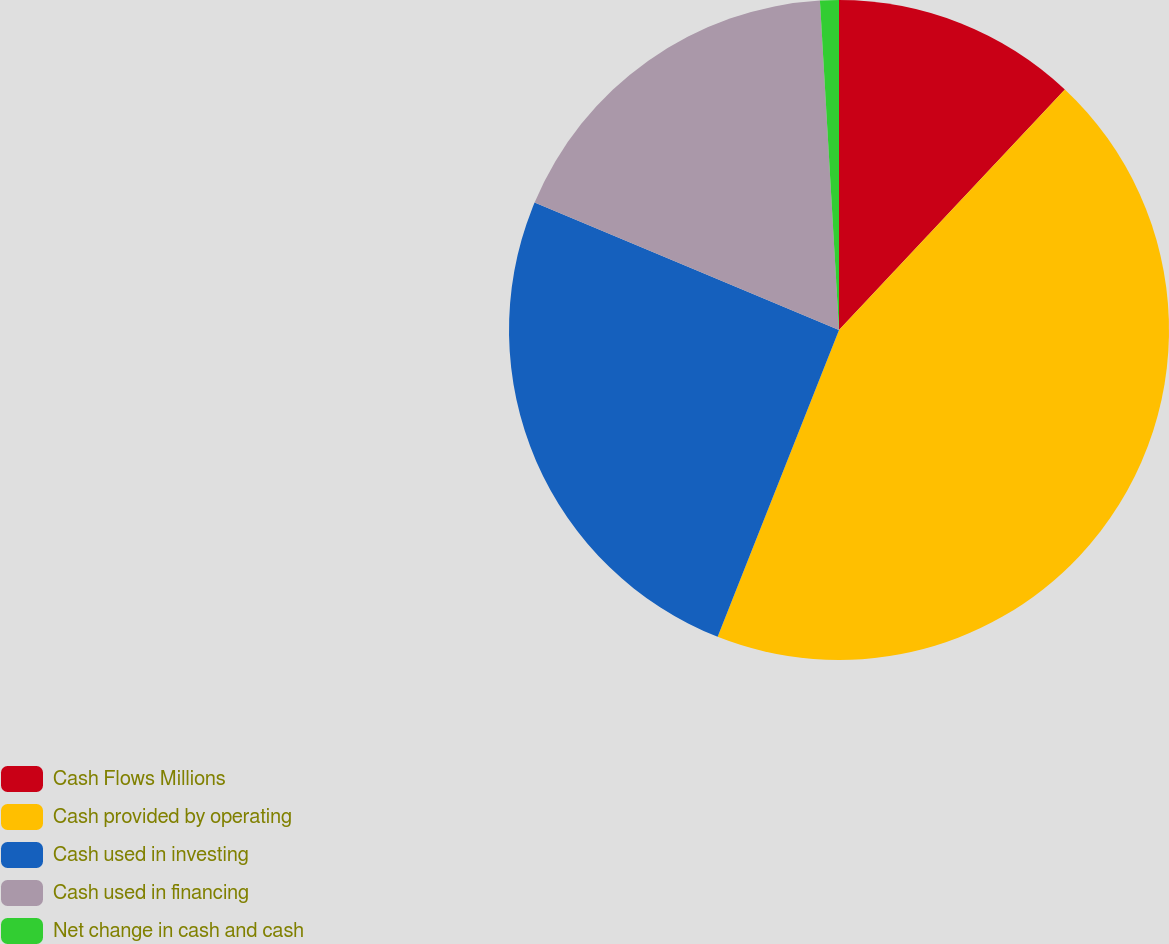Convert chart to OTSL. <chart><loc_0><loc_0><loc_500><loc_500><pie_chart><fcel>Cash Flows Millions<fcel>Cash provided by operating<fcel>Cash used in investing<fcel>Cash used in financing<fcel>Net change in cash and cash<nl><fcel>12.0%<fcel>44.0%<fcel>25.32%<fcel>17.77%<fcel>0.92%<nl></chart> 